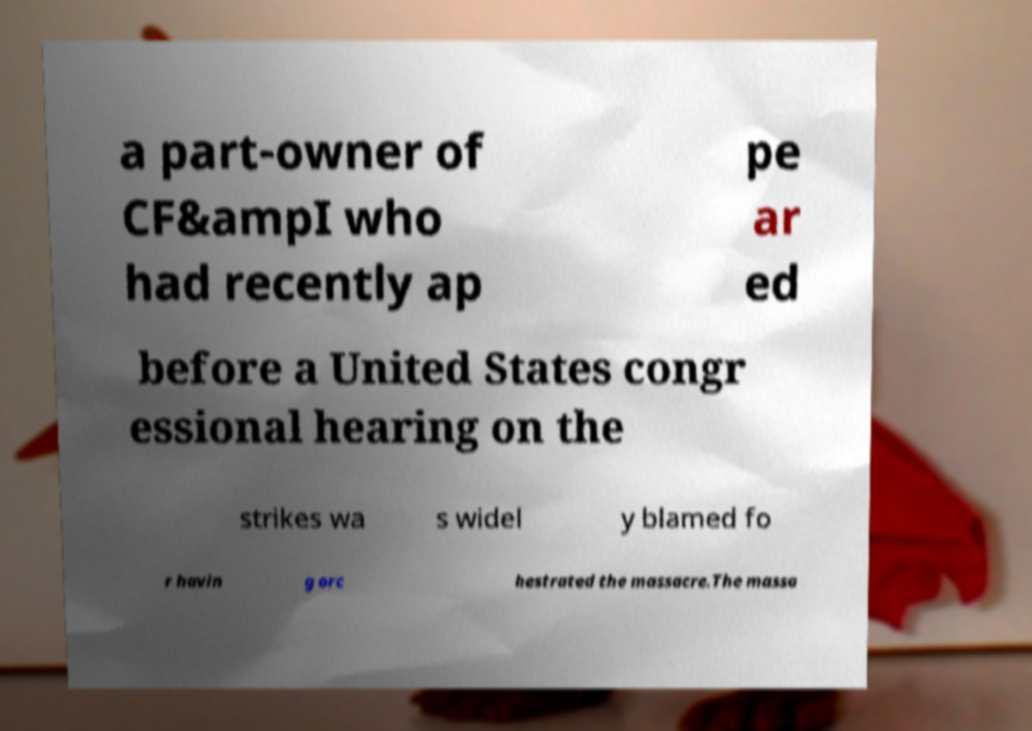Can you accurately transcribe the text from the provided image for me? a part-owner of CF&ampI who had recently ap pe ar ed before a United States congr essional hearing on the strikes wa s widel y blamed fo r havin g orc hestrated the massacre.The massa 